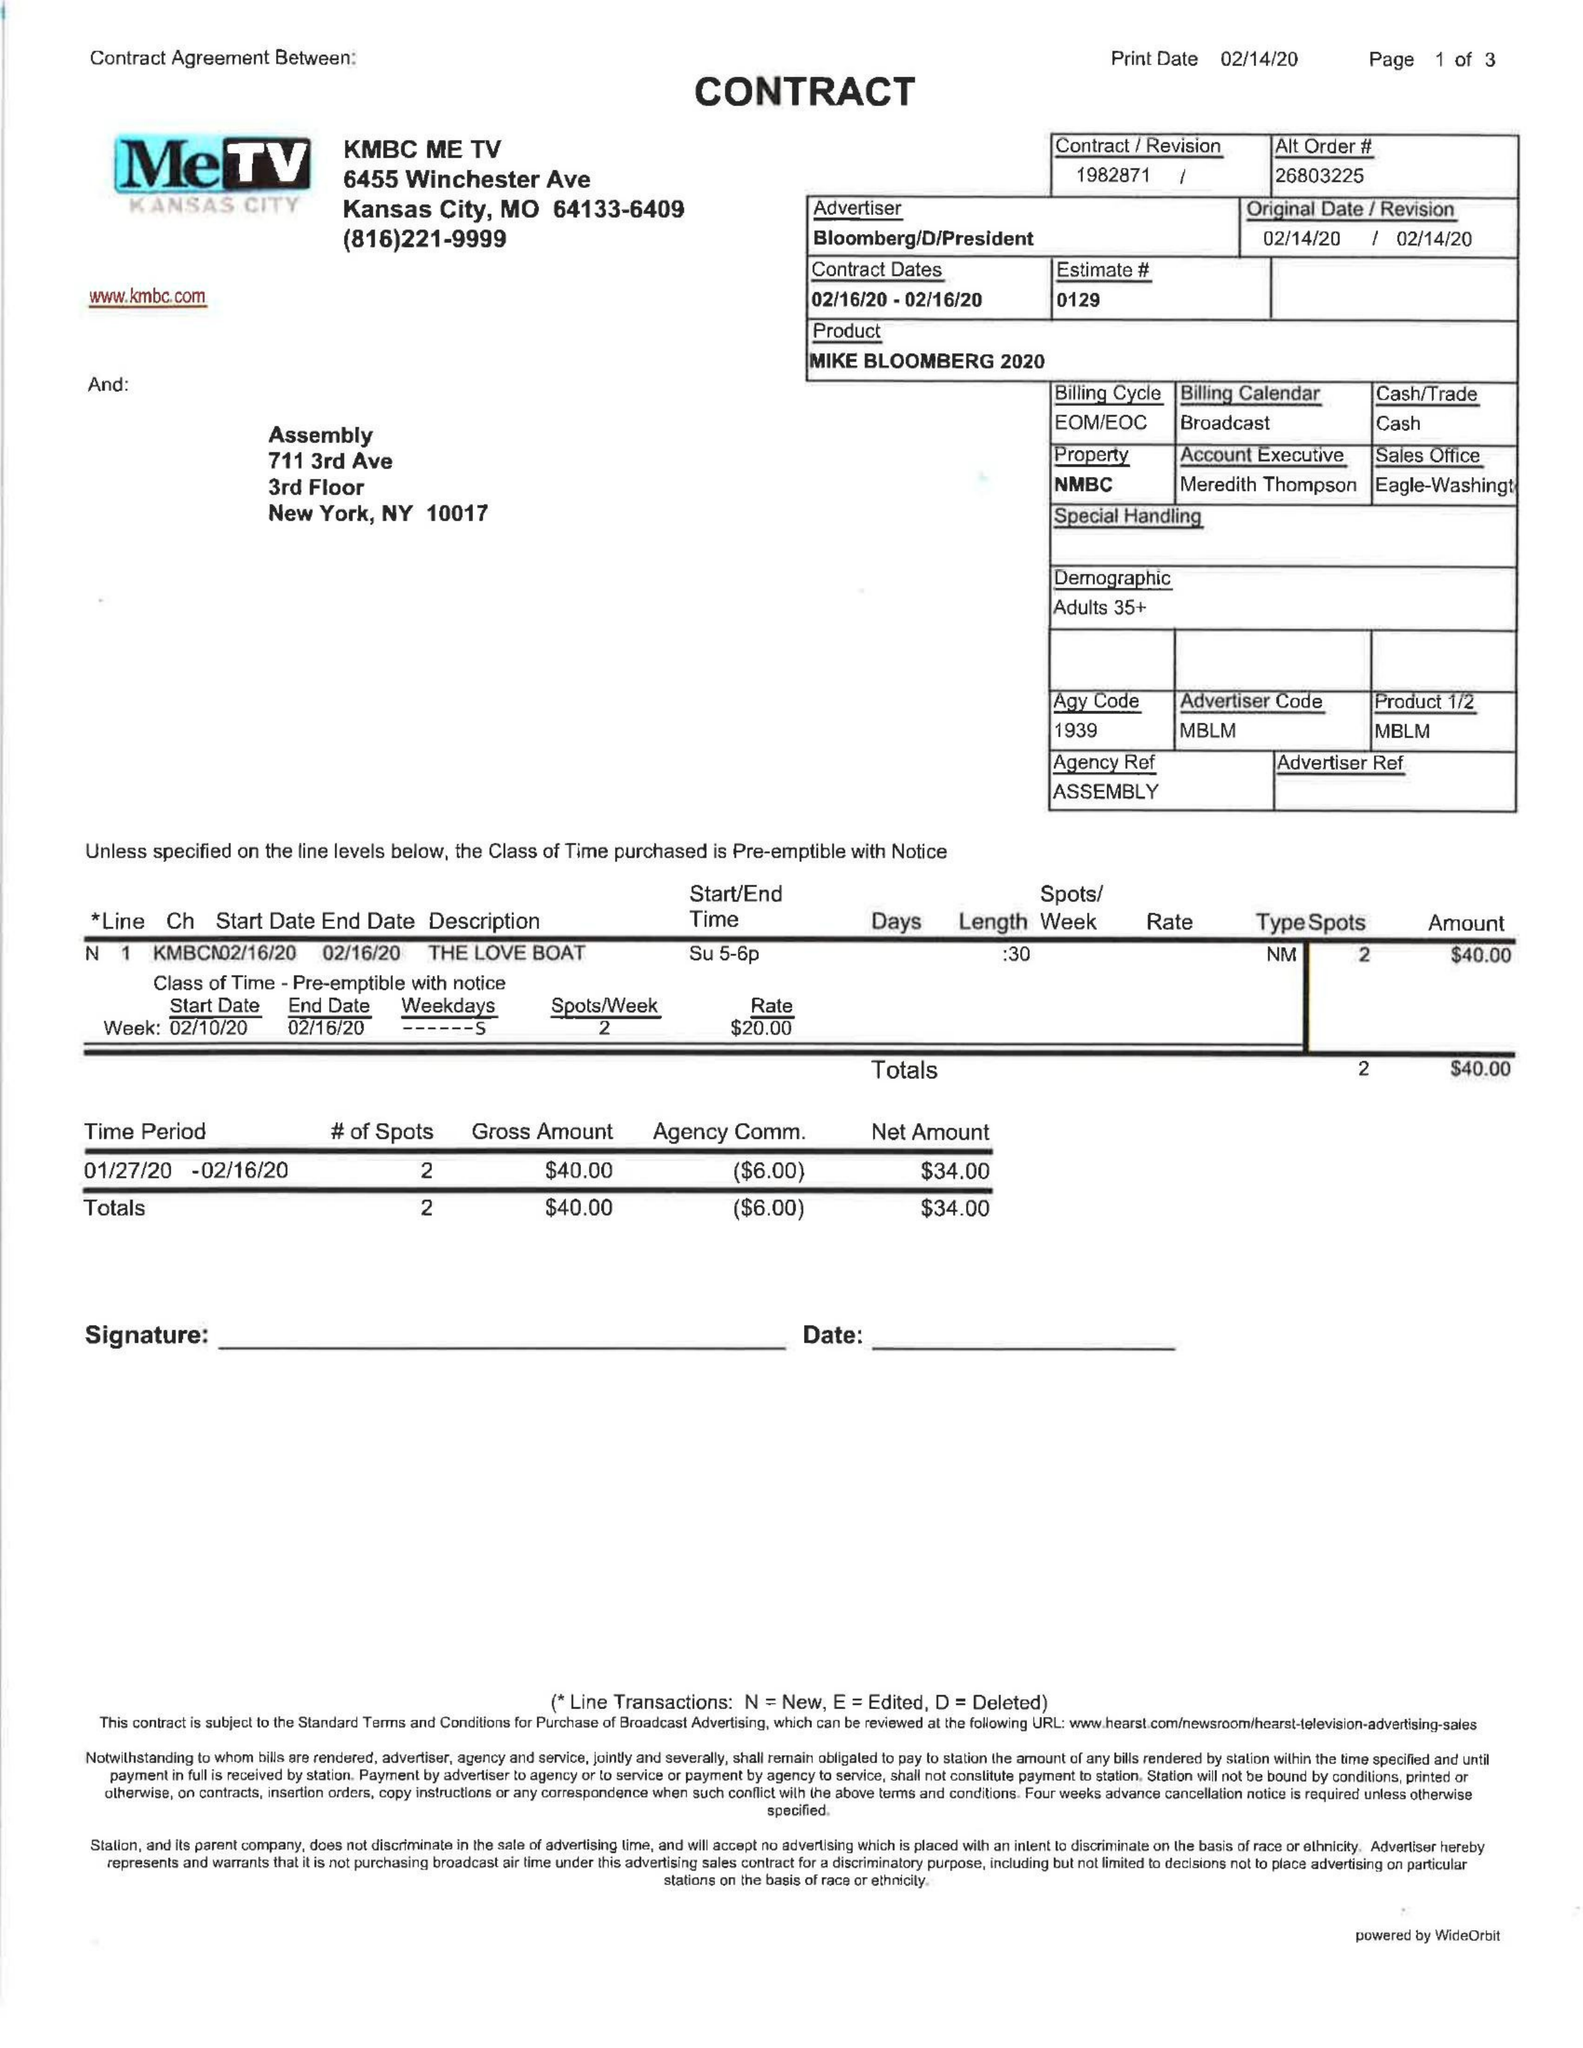What is the value for the gross_amount?
Answer the question using a single word or phrase. 40.00 